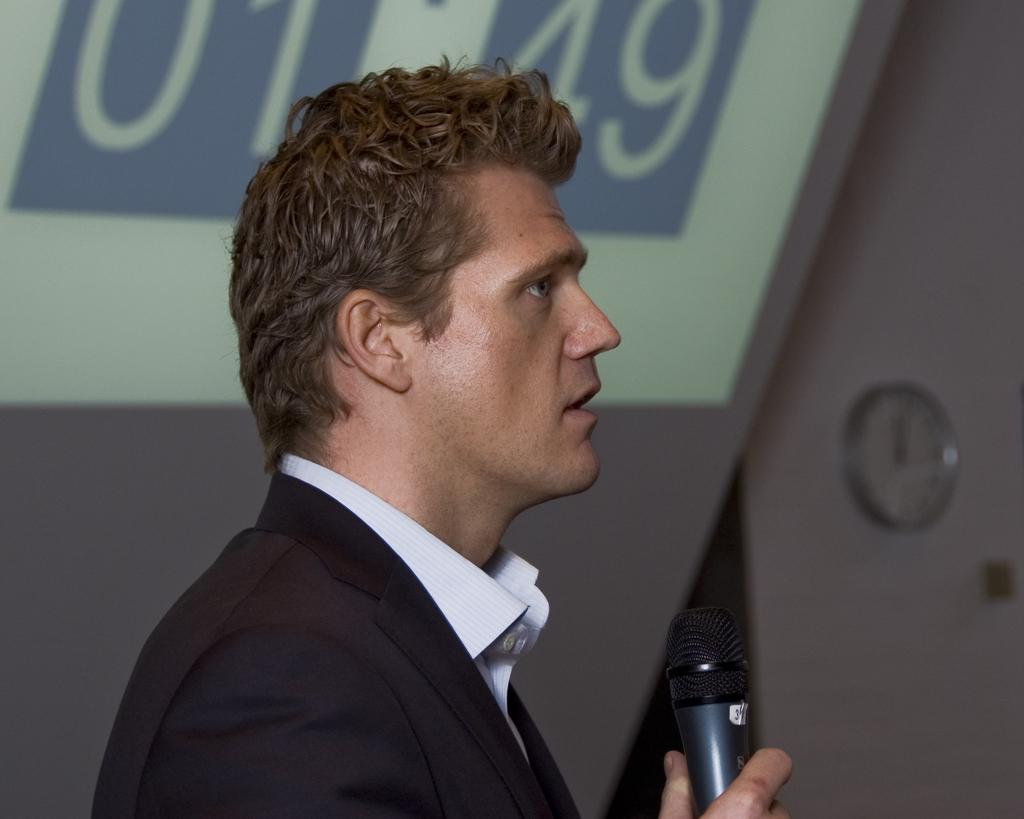Who is present in the image? There is a man in the image. What is the man wearing? The man is wearing a black color blazer. What is the man holding in his hand? The man is holding a microphone in his hand. What can be seen on the wall in the image? There is a clock on the wall in the image. What type of leather is the man using to talk about fiction in the image? There is no leather or discussion about fiction present in the image. 